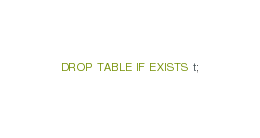Convert code to text. <code><loc_0><loc_0><loc_500><loc_500><_SQL_>DROP TABLE IF EXISTS t;
</code> 